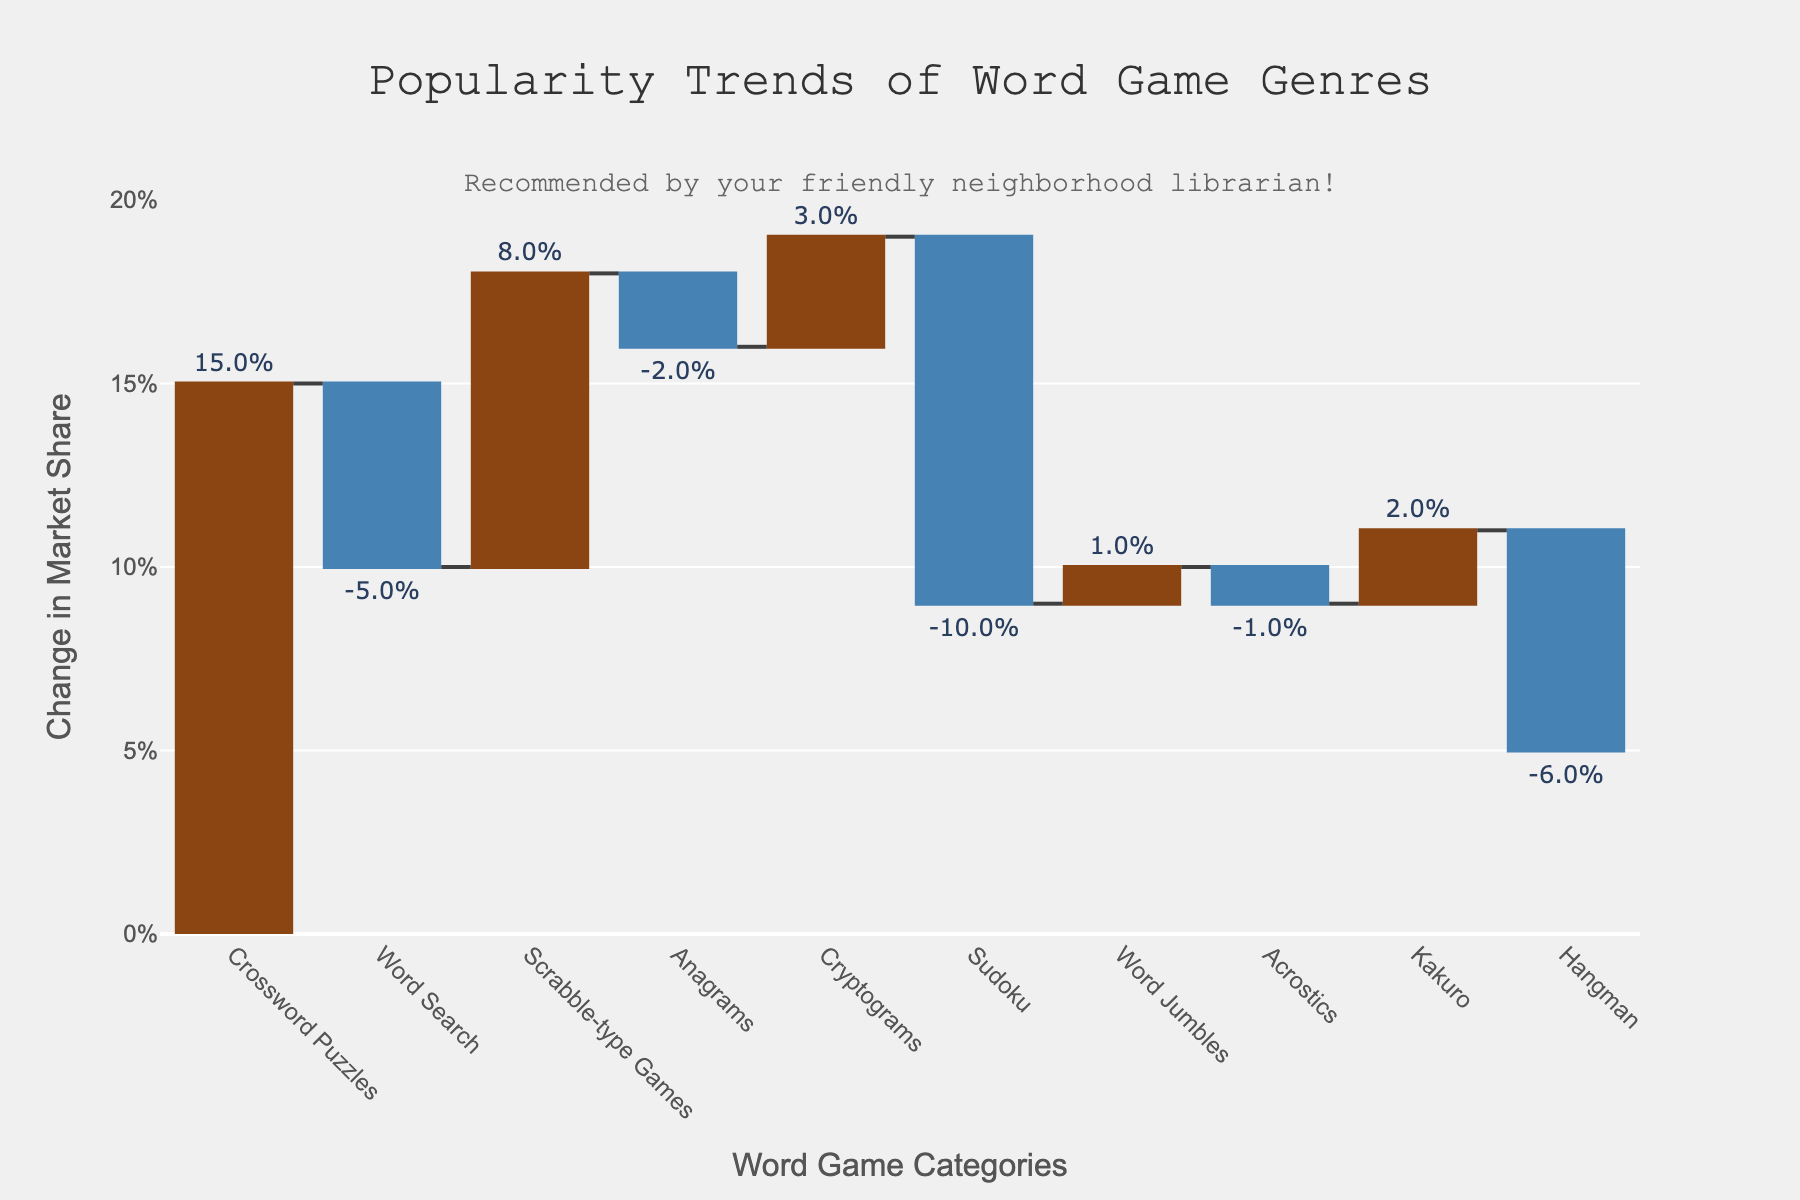Which word game genre showed the highest increase in market share? Look at the category with the highest positive bar. "Crossword Puzzles" has a 15% increase.
Answer: Crossword Puzzles Which word game genre had the largest decrease in market share? Find the category with the largest negative bar. "Sudoku" decreased by 10%.
Answer: Sudoku How did the market share for Word Search and Hangman change overall? Identify the percentage changes for both categories: Word Search (-5%) and Hangman (-6%). Add the percentage values: -5% + -6% = -11%.
Answer: -11% What is the combined market share change for all genres showing a positive increase? Sum the percentage changes of genres with positive values: (+15% Crossword Puzzles) + (+8% Scrabble-type Games) + (+3% Cryptograms) + (+1% Word Jumbles) + (+2% Kakuro) = 29%.
Answer: 29% Which word game genres showed a change of less than 2%? Identify the genres with changes in market share less than 2%. They are Word Jumbles (+1%), Acrostics (-1%), and Kakuro (+2%).
Answer: Word Jumbles, Acrostics, Kakuro How many word game genres had an increase in market share over the past decade? Count the number of categories with positive percentage changes. There are five such categories: Crossword Puzzles, Scrabble-type Games, Cryptograms, Word Jumbles, and Kakuro.
Answer: 5 Which word game genres experienced a decline in market share? Identify the categories with negative bars: Word Search, Anagrams, Sudoku, Acrostics, and Hangman.
Answer: Word Search, Anagrams, Sudoku, Acrostics, Hangman By how much did Crossword Puzzles outperform Sudoku in terms of market share change? Subtract the percentage change of Sudoku from that of Crossword Puzzles: (+15%) - (-10%) = +25%.
Answer: 25% What is the average change in market share for all word game genres? First, sum all market share changes: 15% - 5% + 8% - 2% + 3% - 10% + 1% - 1% + 2% - 6% = 5%. Divide by the number of genres (10): 5% / 10 = 0.5%.
Answer: 0.5% Which word game genre's market share changed closer to zero, Anagrams or Acrostics? Compare the absolute values of market share changes for Anagrams (-2%) and Acrostics (-1%). -1% is closer to zero than -2%.
Answer: Acrostics 